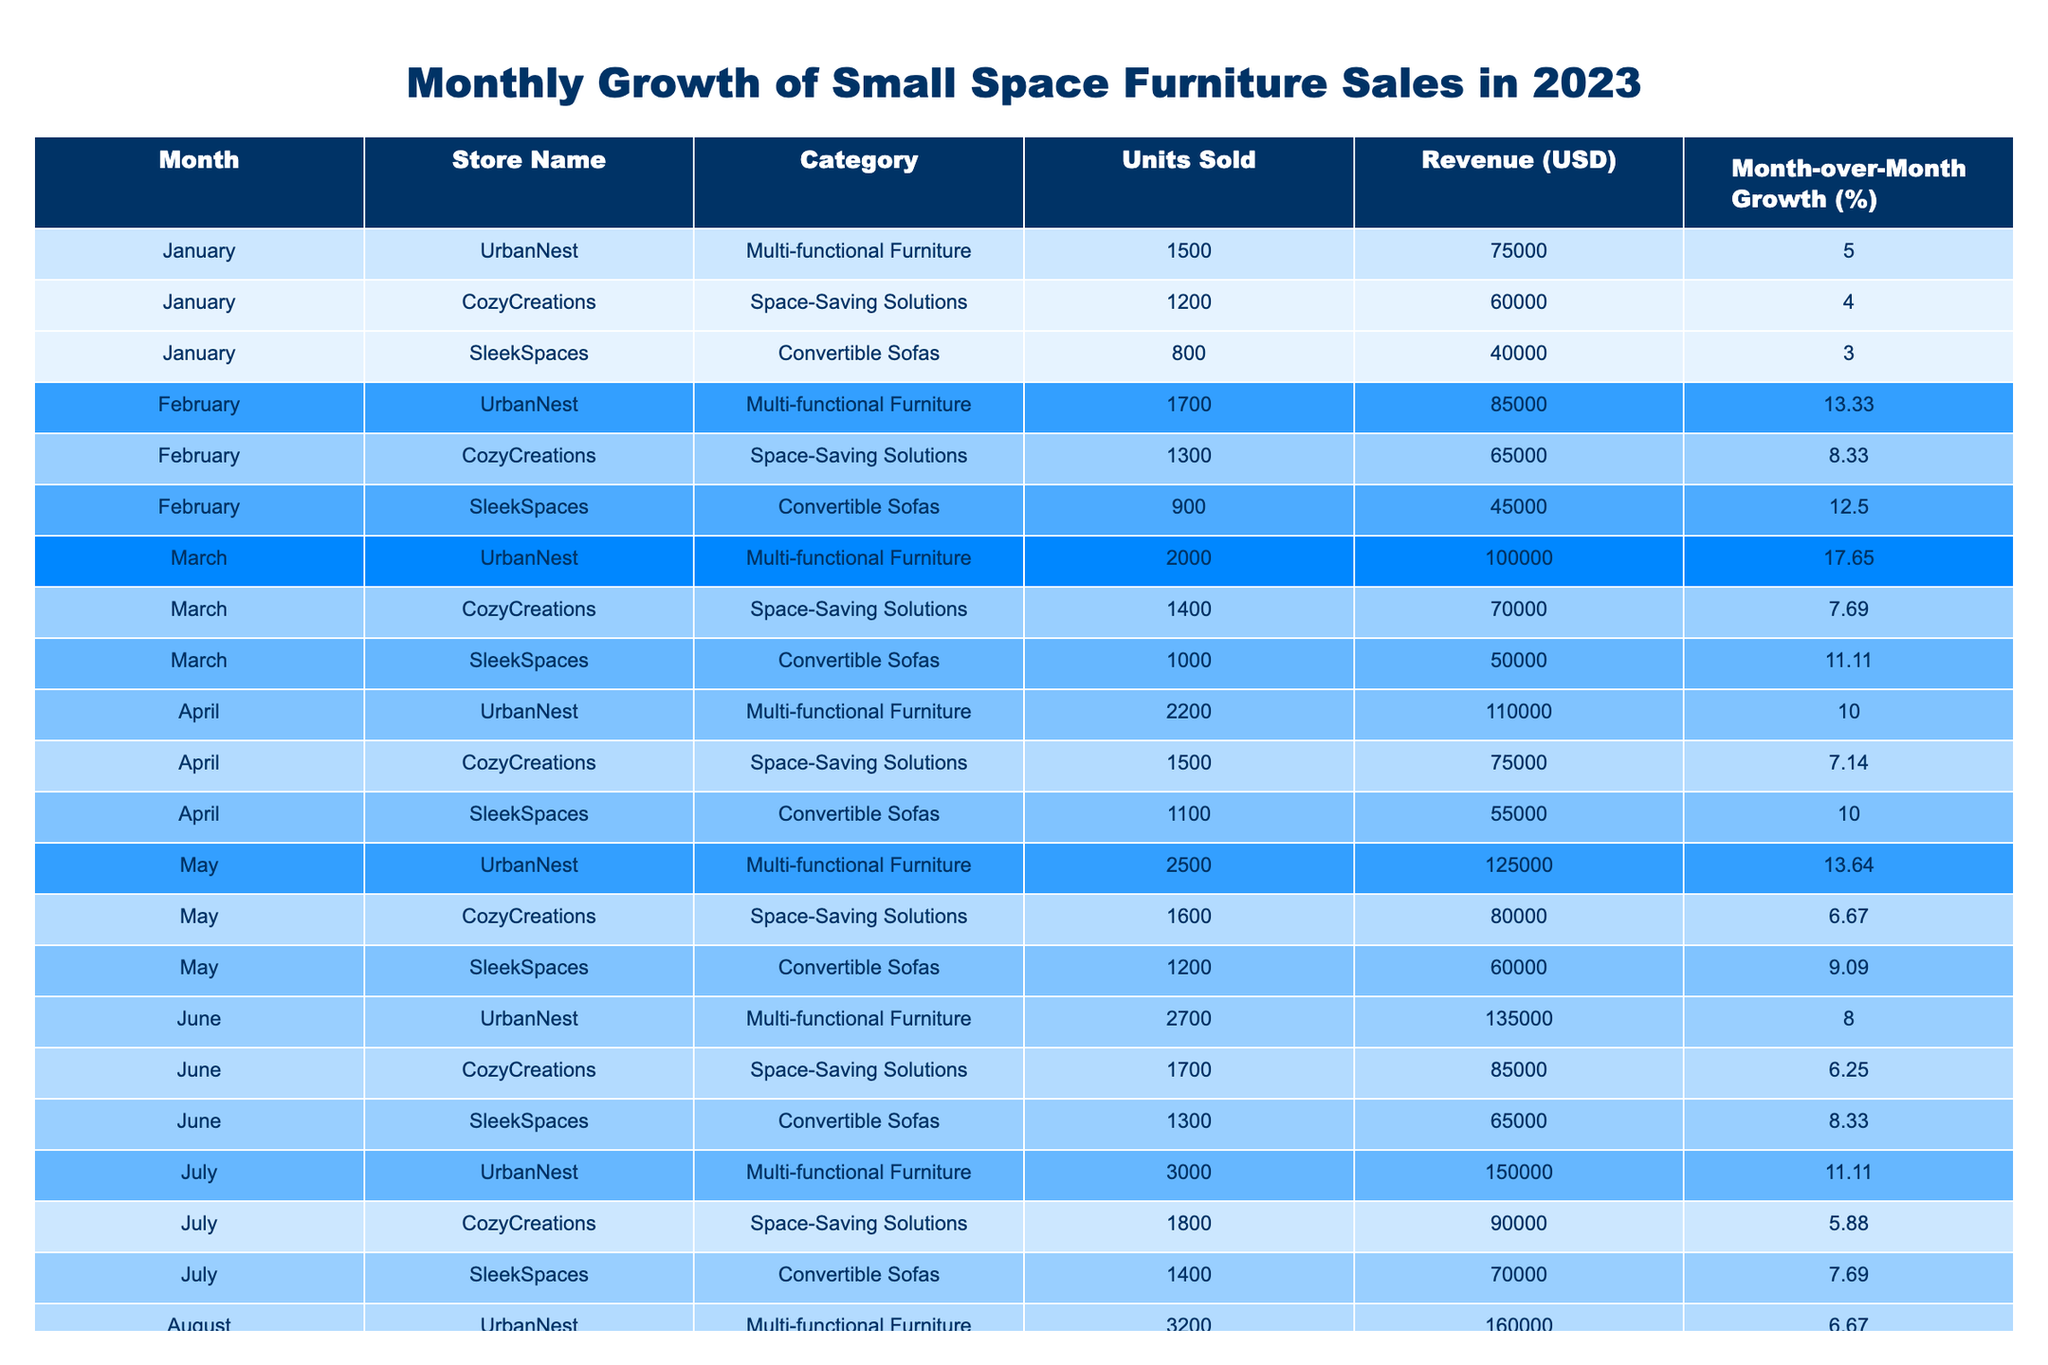What was the highest revenue generated in a single month for UrbanNest? The table shows that in October, UrbanNest generated a revenue of $200,000, which is the highest among all months.
Answer: $200,000 Which month saw the largest increase in sales for CozyCreations? Looking at the Month-over-Month Growth percentages for CozyCreations, February (8.33%) to March (7.69%) is smaller than January (4%) to February (8.33%). The largest growth is from January to February, where it increased by 4.33%.
Answer: January to February What is the average units sold for SleekSpaces across the months in 2023? Sum the units sold: (800 + 900 + 1000 + 1100 + 1200 + 1300 + 1400 + 1500 + 1600 + 1700 + 1800 + 1900) = 15,300. There are 12 months, so the average is 15,300 / 12 = 1,275 units.
Answer: 1,275 Did CozyCreations experience any month with negative growth in 2023? All Month-over-Month Growth percentages for CozyCreations are positive, indicating no month had negative growth.
Answer: No What was the total revenue generated by UrbanNest in the first half of 2023? The total revenue for UrbanNest in the first half (sum of revenues from January to June) is: 75,000 + 85,000 + 100,000 + 110,000 + 125,000 + 135,000 = 630,000.
Answer: $630,000 In which month did SleekSpaces have the highest percentage growth? SleekSpaces had a high growth of 12.5% from January to February. Analyzing the percentages, this is the highest month-over-month growth for them.
Answer: February For which store was the lowest units sold recorded in any month? The lowest units sold were recorded for SleekSpaces in January with 800 units. Analyzing all months across stores, this is the lowest value.
Answer: SleekSpaces What is the difference in units sold between UrbanNest and CozyCreations in November? In November, UrbanNest sold 4,200 units and CozyCreations sold 2,200 units. The difference is 4,200 - 2,200 = 2,000 units.
Answer: 2,000 Which month had the highest growth rate for Multi-functional Furniture category? According to the data, the highest growth rate for the Multi-functional Furniture category is from February to March at 17.65%, comparing all months for UrbanNest.
Answer: March How many total units were sold across all stores in December? For December, add the units sold: UrbanNest (4,500) + CozyCreations (2,300) + SleekSpaces (1,900) = 8,700 units in total.
Answer: 8,700 